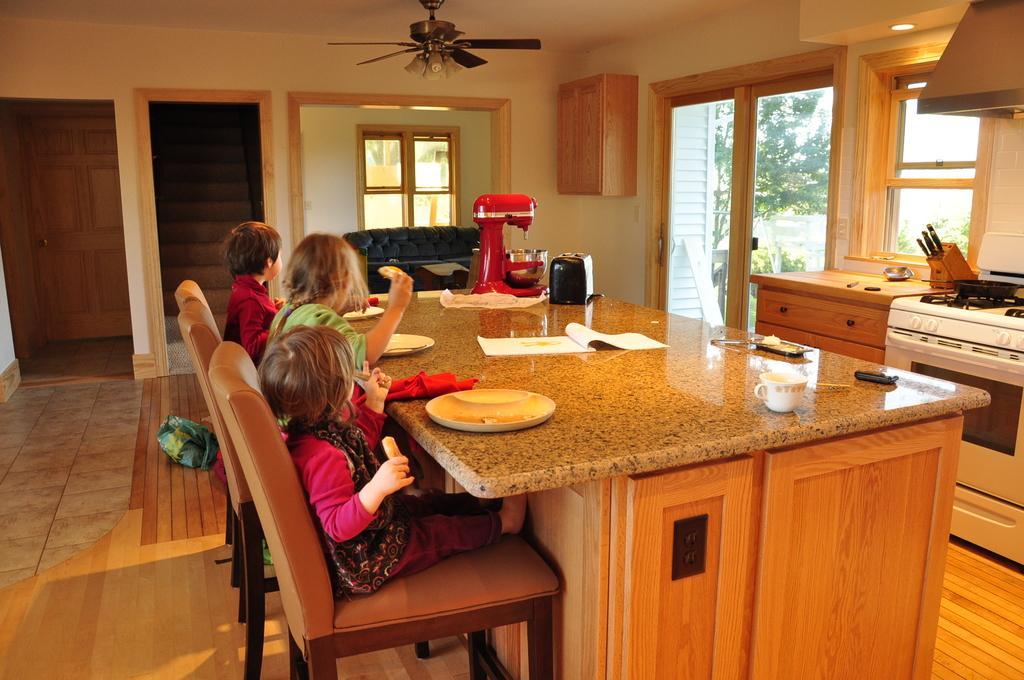Please provide a concise description of this image. In this image there are three children sitting on the chair. On the table there is plate,book,cup and a machine. At the back side there is stairs and there is wooden door. On the right side there stove and a oven. There are trees. 